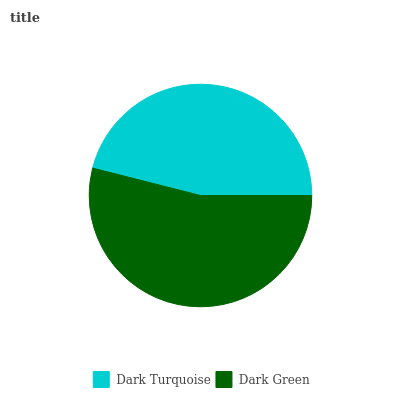Is Dark Turquoise the minimum?
Answer yes or no. Yes. Is Dark Green the maximum?
Answer yes or no. Yes. Is Dark Green the minimum?
Answer yes or no. No. Is Dark Green greater than Dark Turquoise?
Answer yes or no. Yes. Is Dark Turquoise less than Dark Green?
Answer yes or no. Yes. Is Dark Turquoise greater than Dark Green?
Answer yes or no. No. Is Dark Green less than Dark Turquoise?
Answer yes or no. No. Is Dark Green the high median?
Answer yes or no. Yes. Is Dark Turquoise the low median?
Answer yes or no. Yes. Is Dark Turquoise the high median?
Answer yes or no. No. Is Dark Green the low median?
Answer yes or no. No. 